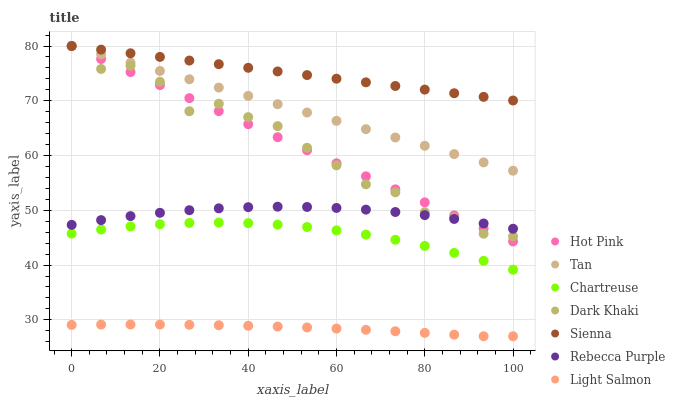Does Light Salmon have the minimum area under the curve?
Answer yes or no. Yes. Does Sienna have the maximum area under the curve?
Answer yes or no. Yes. Does Hot Pink have the minimum area under the curve?
Answer yes or no. No. Does Hot Pink have the maximum area under the curve?
Answer yes or no. No. Is Hot Pink the smoothest?
Answer yes or no. Yes. Is Dark Khaki the roughest?
Answer yes or no. Yes. Is Light Salmon the smoothest?
Answer yes or no. No. Is Light Salmon the roughest?
Answer yes or no. No. Does Light Salmon have the lowest value?
Answer yes or no. Yes. Does Hot Pink have the lowest value?
Answer yes or no. No. Does Tan have the highest value?
Answer yes or no. Yes. Does Light Salmon have the highest value?
Answer yes or no. No. Is Chartreuse less than Tan?
Answer yes or no. Yes. Is Hot Pink greater than Chartreuse?
Answer yes or no. Yes. Does Dark Khaki intersect Rebecca Purple?
Answer yes or no. Yes. Is Dark Khaki less than Rebecca Purple?
Answer yes or no. No. Is Dark Khaki greater than Rebecca Purple?
Answer yes or no. No. Does Chartreuse intersect Tan?
Answer yes or no. No. 